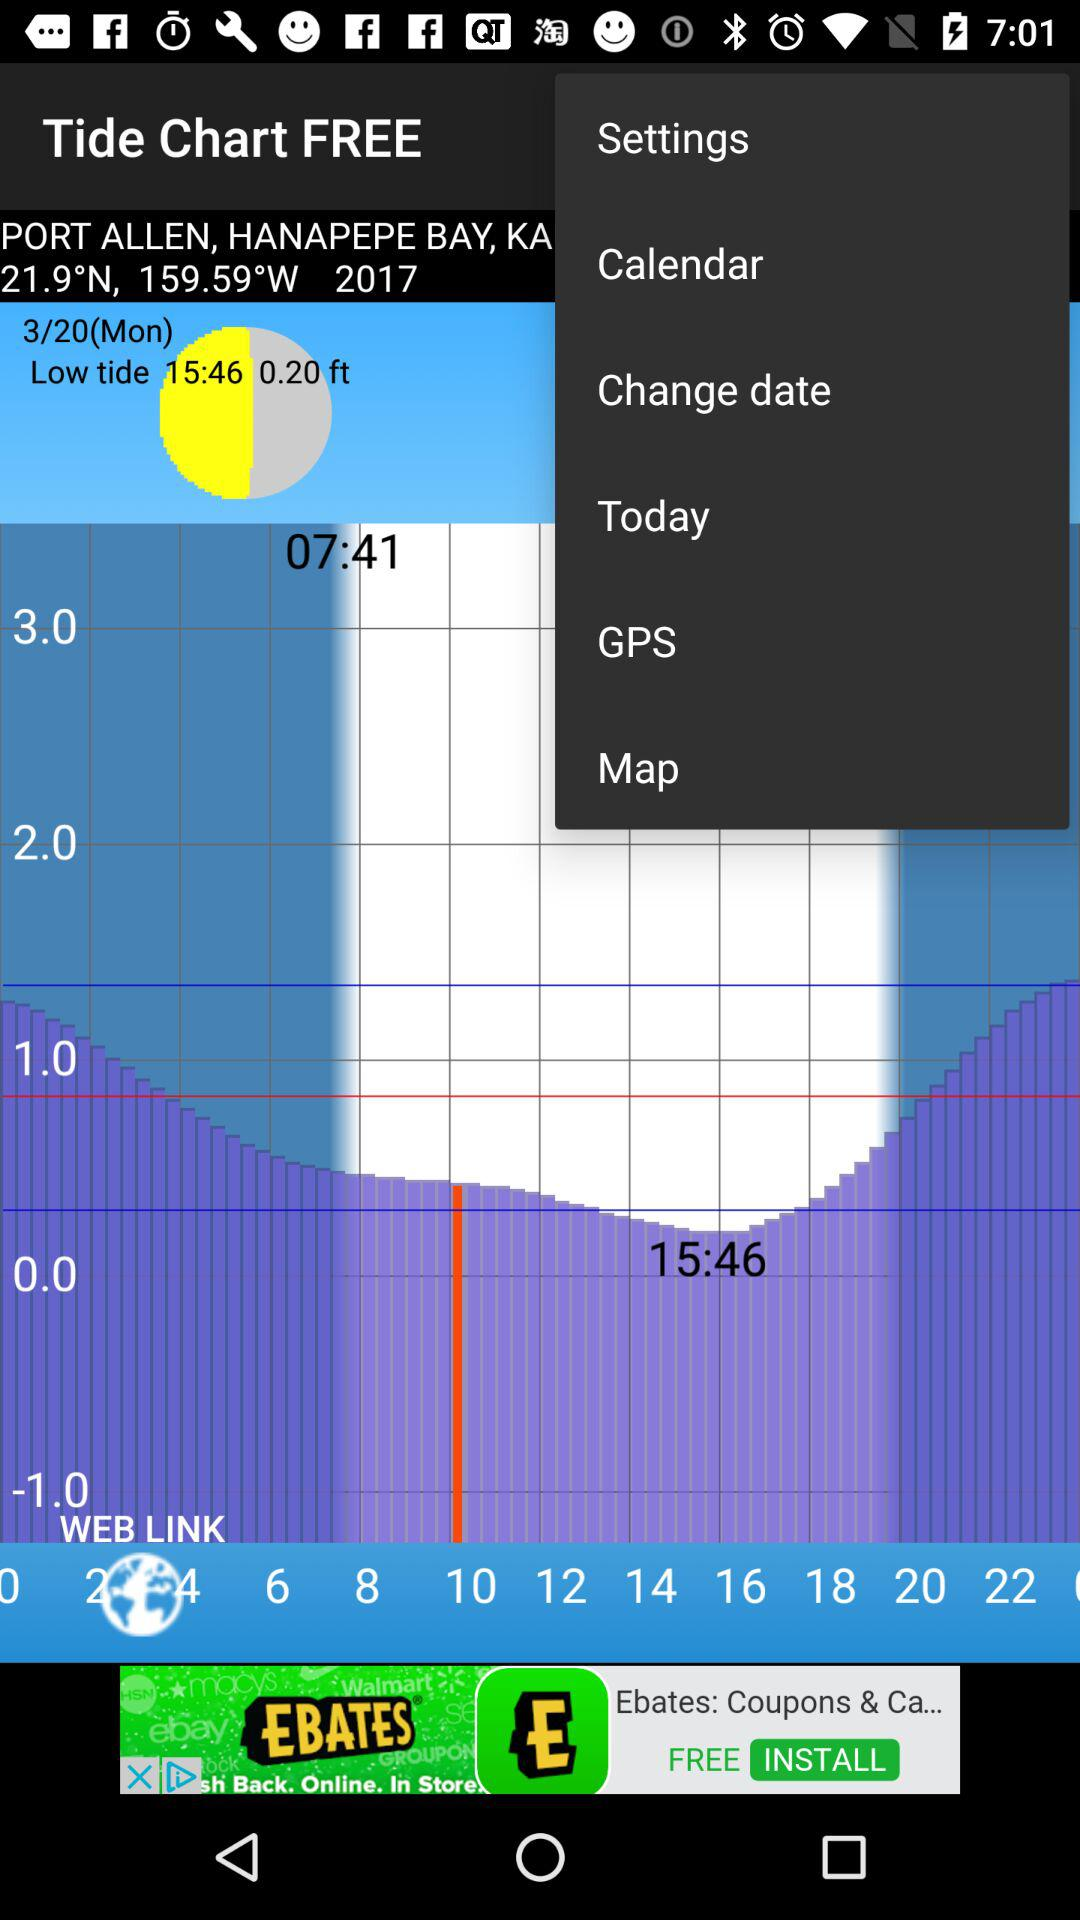What is the day on 3/20? The day is Monday. 